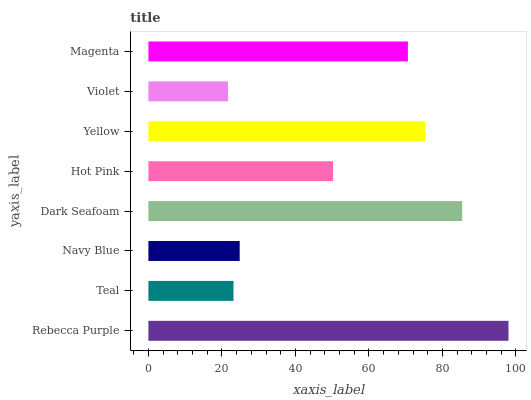Is Violet the minimum?
Answer yes or no. Yes. Is Rebecca Purple the maximum?
Answer yes or no. Yes. Is Teal the minimum?
Answer yes or no. No. Is Teal the maximum?
Answer yes or no. No. Is Rebecca Purple greater than Teal?
Answer yes or no. Yes. Is Teal less than Rebecca Purple?
Answer yes or no. Yes. Is Teal greater than Rebecca Purple?
Answer yes or no. No. Is Rebecca Purple less than Teal?
Answer yes or no. No. Is Magenta the high median?
Answer yes or no. Yes. Is Hot Pink the low median?
Answer yes or no. Yes. Is Navy Blue the high median?
Answer yes or no. No. Is Violet the low median?
Answer yes or no. No. 